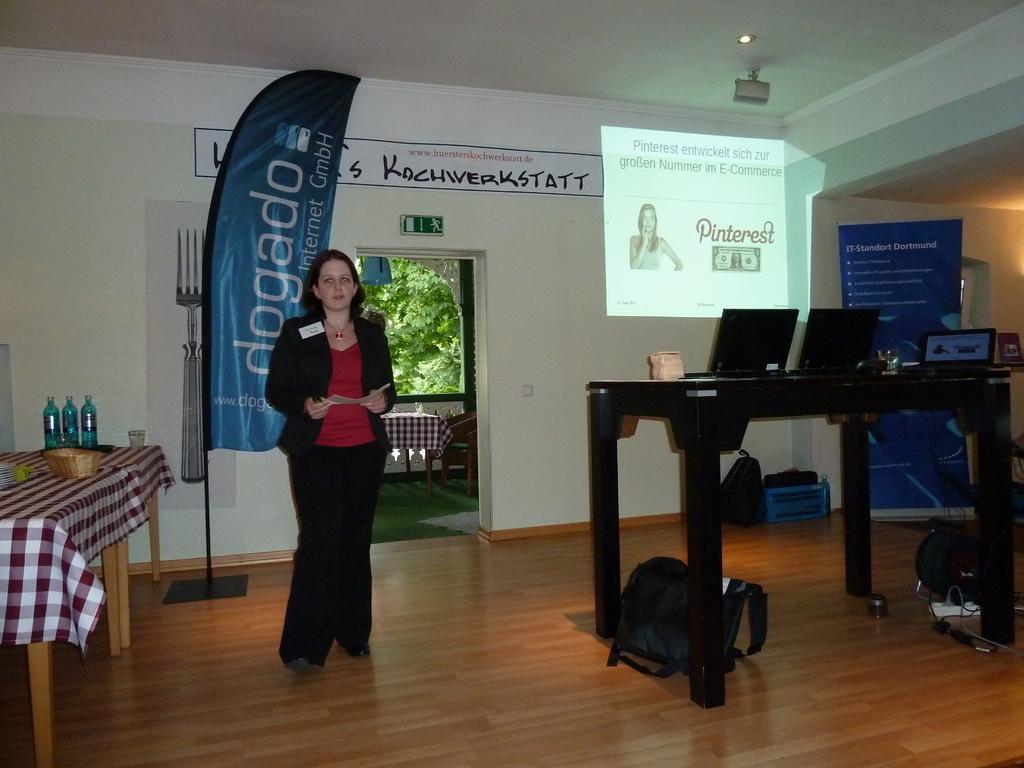Could you give a brief overview of what you see in this image? This is the woman holding a paper and standing. She wore T-shirt, jacket, trouser and shoes. This looks like a flag hanging to the pole. I can see a table covered with a cloth. This looks like a basket, three bottles and a glass are placed on the table. I think this is a hoarding. These are the bags placed on the floor. This is a table with three laptops on it. I think this is the screen. This is the poster attached to the wall. This looks like a balcony. Here is another table with a cloth on it. These are the chairs. I can see the trees through the balcony. 